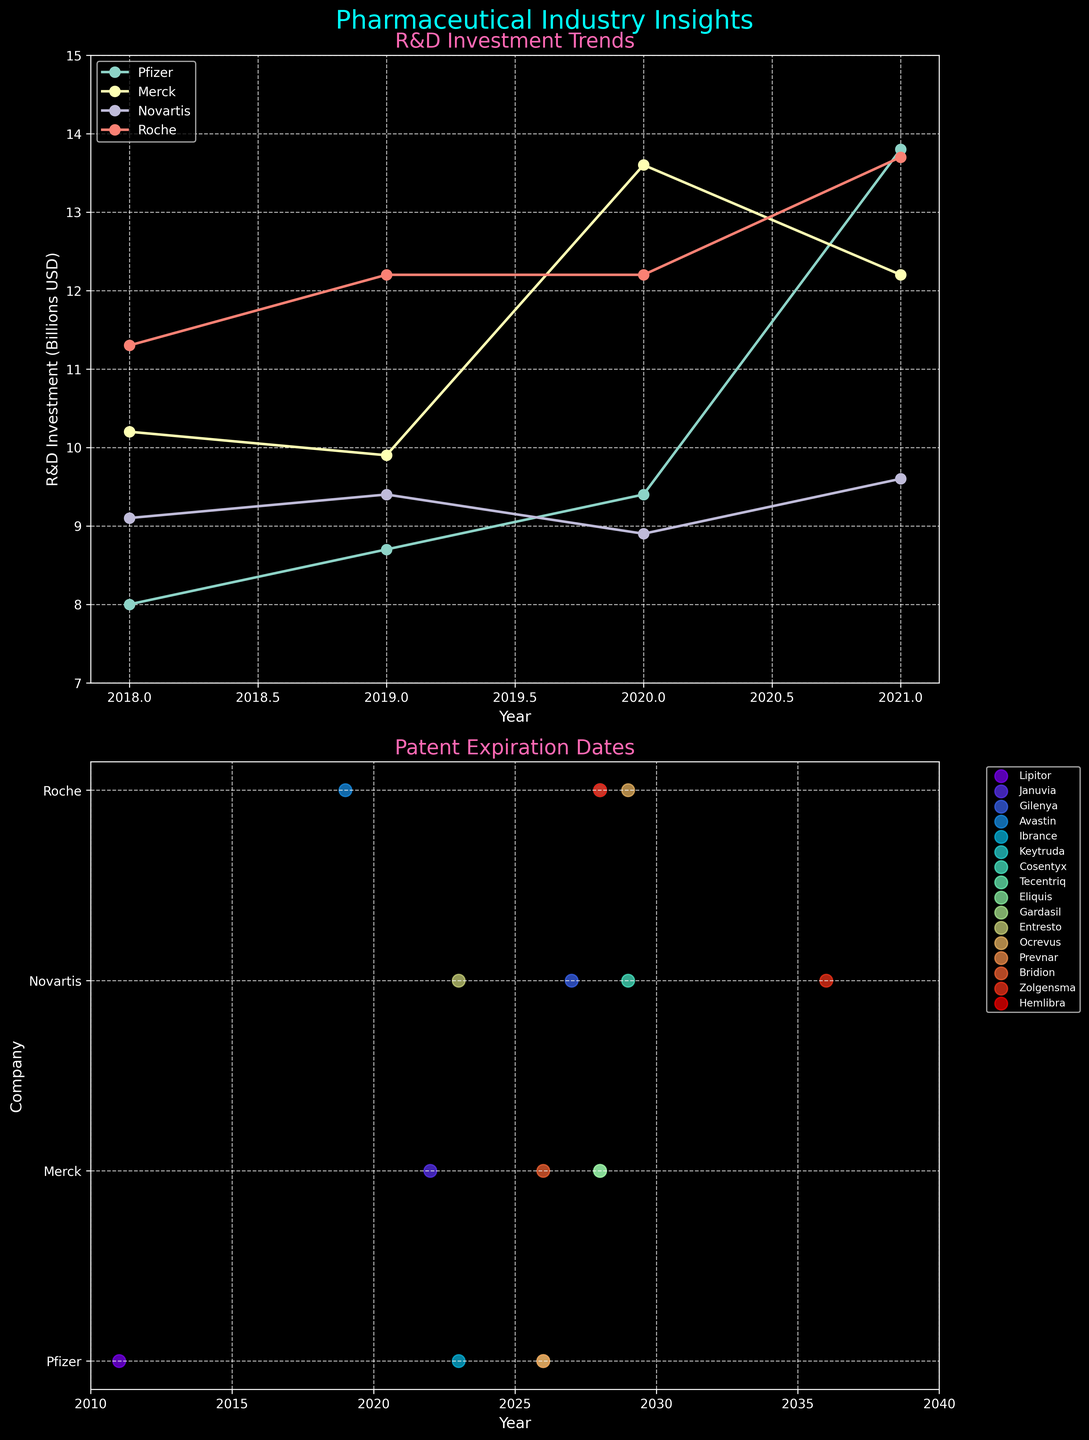What is the title of the first subplot? The title of the first subplot is displayed prominently at the top of the subplot in a slightly larger font.
Answer: R&D Investment Trends Which company had the highest R&D investment in 2019? By examining the peaks and comparing the lines for the year 2019, Roche's line peaks the highest on the y-axis at 12.2 billion USD.
Answer: Roche What is the general trend for Pfizer's R&D investment from 2018 to 2021? Pfizer's R&D investment increases gradually each year from 2018 to 2021, with a marked spike in 2021.
Answer: Increasing How many drugs have their patent expiration dates plotted on the second subplot? Each unique marker in the second subplot represents a drug, and the legend lists them. There are 14 drugs listed in the legend.
Answer: 14 In which year does Novartis have a drug patent expiring? By looking at the scatter points in the second subplot and their corresponding labels, Entresto, a Novartis drug, has its patent expiring in 2023, and Zolgensma in 2036.
Answer: 2023 and 2036 What is the difference in R&D investment between the company with the highest and lowest investment in 2020? By checking the y-values for the respective companies in 2020, Roche has around 12.2 billion USD and Novartis has about 8.9 billion USD. The difference is 12.2 - 8.9 = 3.3 billion USD.
Answer: 3.3 billion USD Between 2019 and 2021, which company shows a consistent increase in R&D investment each year? Analyzing the lines of each company from 2019 to 2021, Pfizer's line continuously rises each year, indicating a consistent increase.
Answer: Pfizer Which year's investments appear to be the most spread out across companies? By comparing the differences in heights of the lines (R&D investments) across all years, 2021 shows the most spread, ranging from about 9.6 to 13.8 billion USD.
Answer: 2021 List the companies that have drug patents expiring in 2028. Observing the scatter points and their corresponding labels in the second subplot, the legend shows Merck and Roche both have drug patents expiring in 2028 (Keytruda, Gardasil, Tecentriq, Hemlibra).
Answer: Merck and Roche Which drug has the latest patent expiration date according to the second subplot? The furthest right scatter point in the second subplot indicates Zolgensma's patent expiring in 2036.
Answer: Zolgensma 